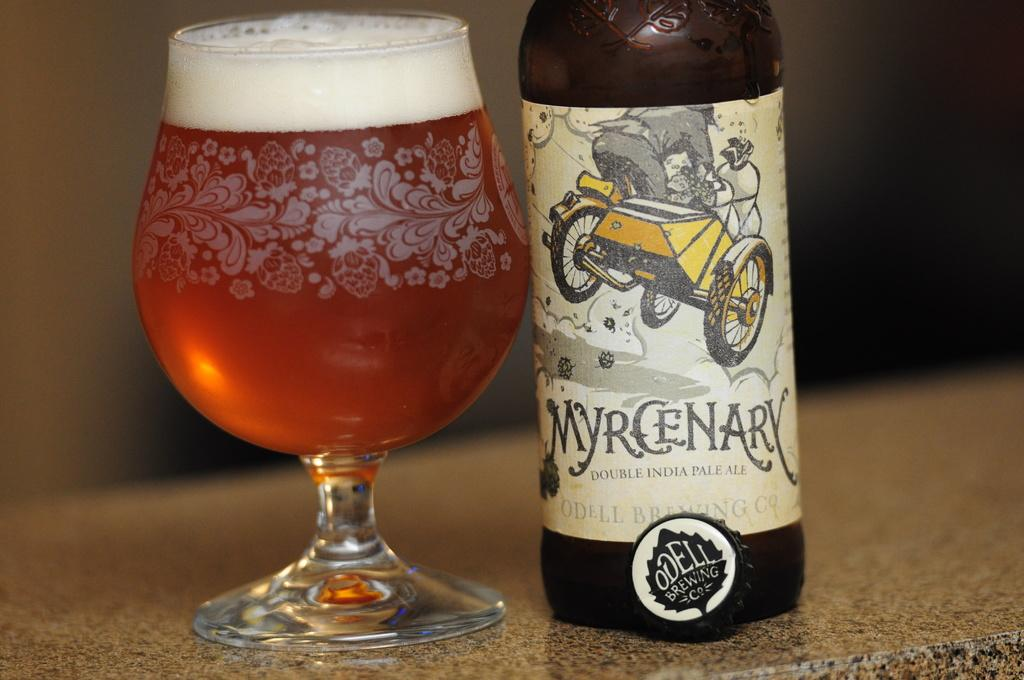Provide a one-sentence caption for the provided image. the word myrcenary that is next to a cup of beer. 